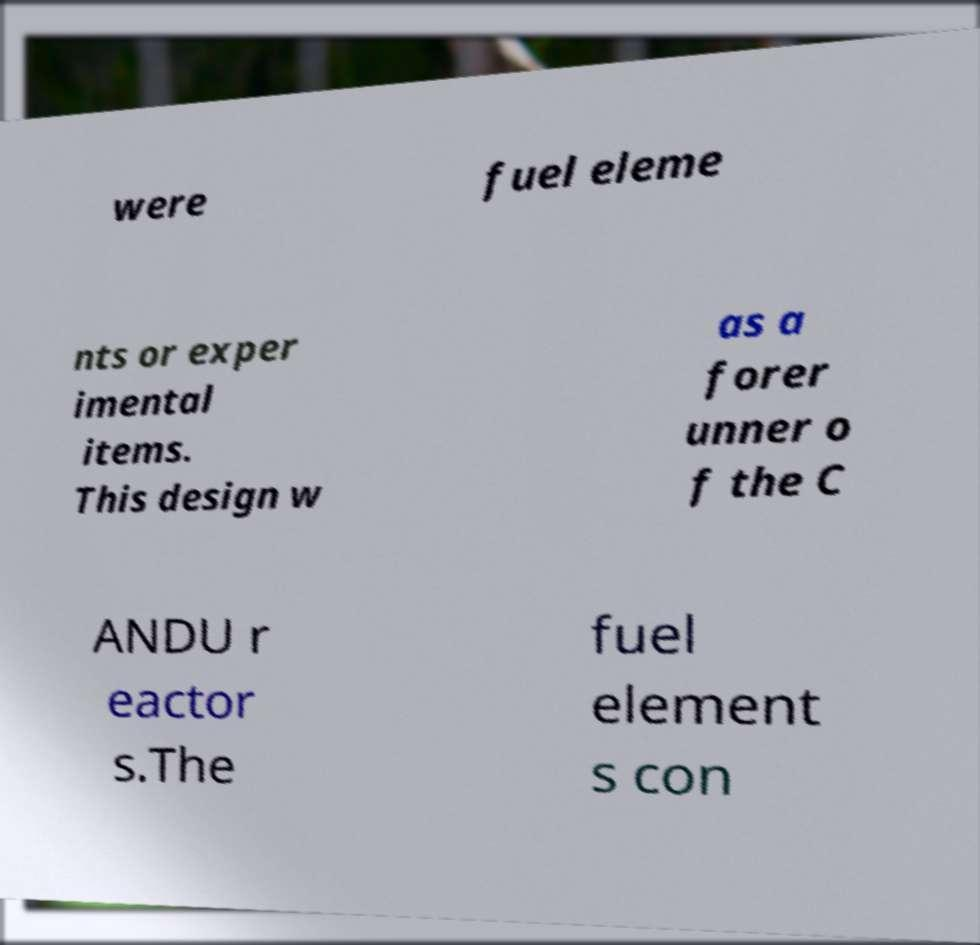What messages or text are displayed in this image? I need them in a readable, typed format. were fuel eleme nts or exper imental items. This design w as a forer unner o f the C ANDU r eactor s.The fuel element s con 